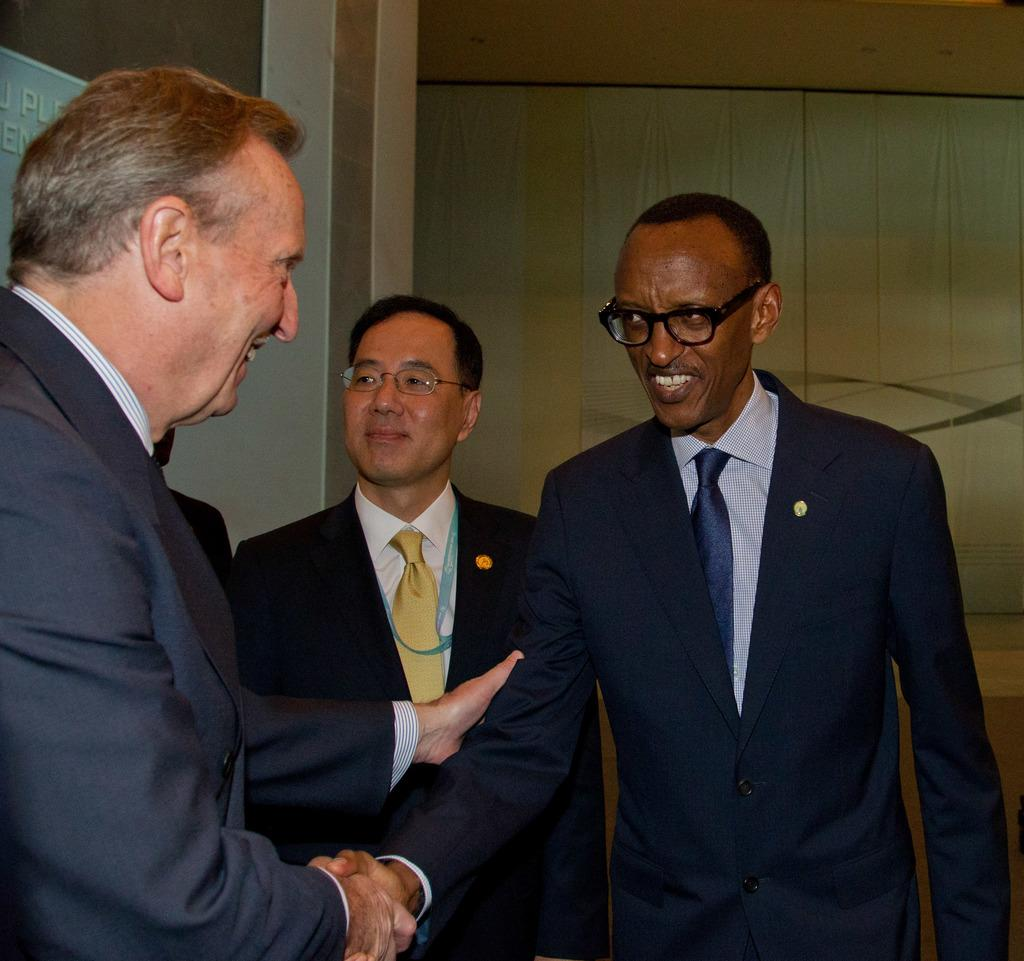How many people are present in the image? There are three people in the image. What is the facial expression of the people in the image? Two of the people are smiling. What are the people in the image doing? Two of the people are shaking hands with each other. What type of badge can be seen on the women in the image? There are no women present in the image, and no badges are visible. Can you tell me how many chess pieces are on the board in the image? There is no chessboard or chess pieces present in the image. 